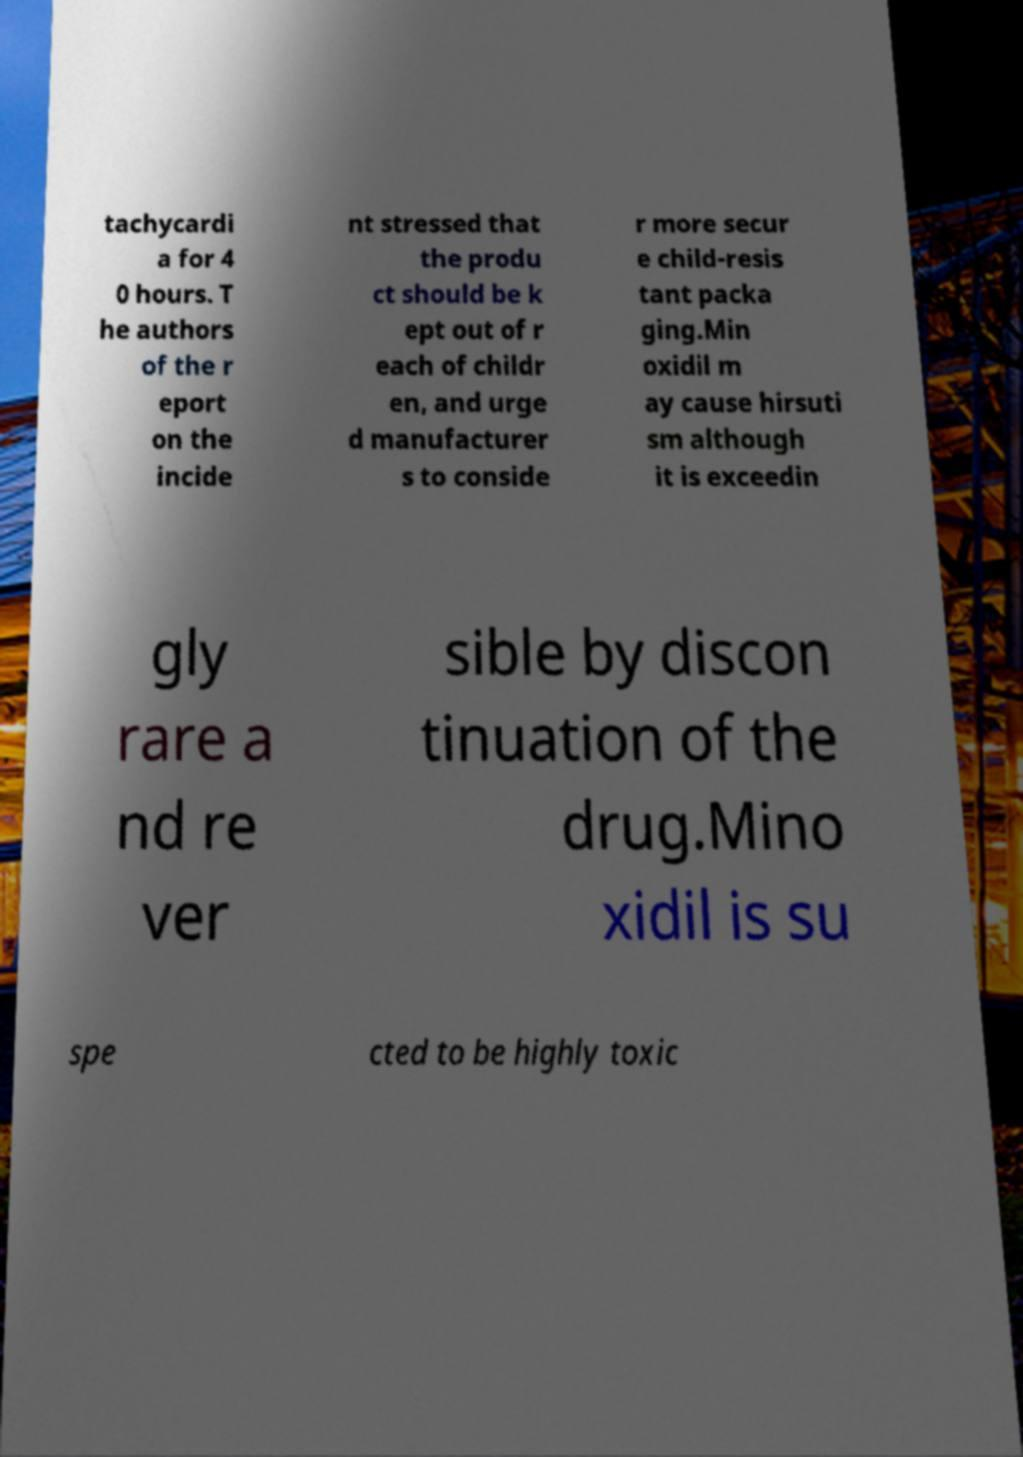For documentation purposes, I need the text within this image transcribed. Could you provide that? tachycardi a for 4 0 hours. T he authors of the r eport on the incide nt stressed that the produ ct should be k ept out of r each of childr en, and urge d manufacturer s to conside r more secur e child-resis tant packa ging.Min oxidil m ay cause hirsuti sm although it is exceedin gly rare a nd re ver sible by discon tinuation of the drug.Mino xidil is su spe cted to be highly toxic 